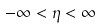<formula> <loc_0><loc_0><loc_500><loc_500>- \infty < \eta < \infty</formula> 